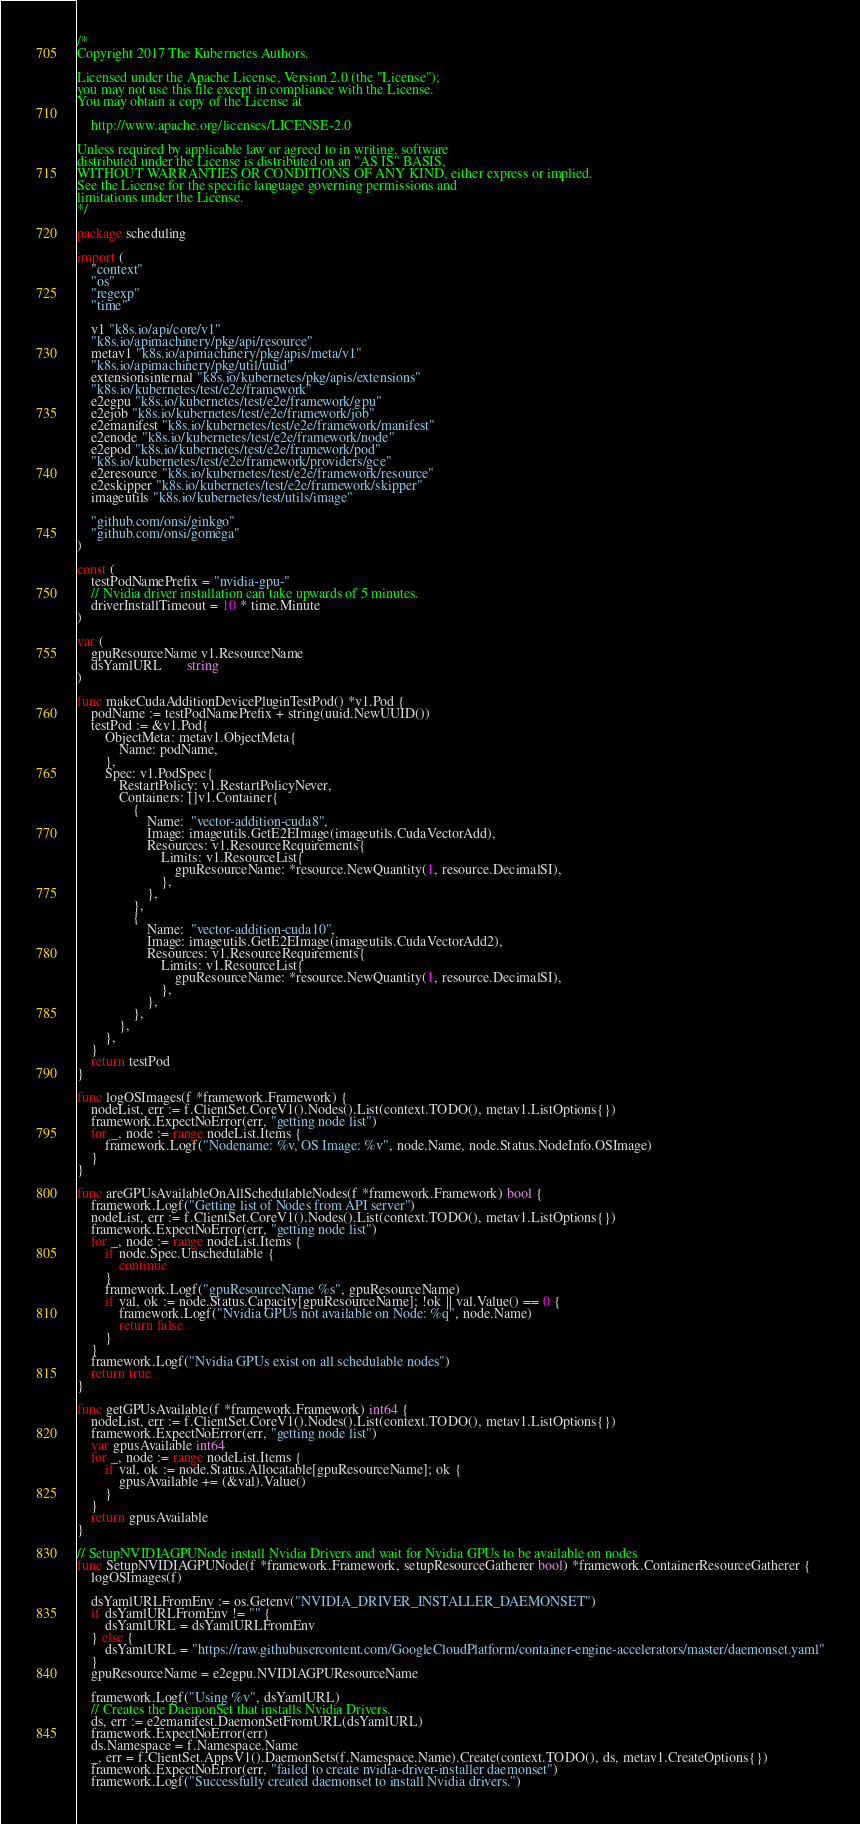<code> <loc_0><loc_0><loc_500><loc_500><_Go_>/*
Copyright 2017 The Kubernetes Authors.

Licensed under the Apache License, Version 2.0 (the "License");
you may not use this file except in compliance with the License.
You may obtain a copy of the License at

    http://www.apache.org/licenses/LICENSE-2.0

Unless required by applicable law or agreed to in writing, software
distributed under the License is distributed on an "AS IS" BASIS,
WITHOUT WARRANTIES OR CONDITIONS OF ANY KIND, either express or implied.
See the License for the specific language governing permissions and
limitations under the License.
*/

package scheduling

import (
	"context"
	"os"
	"regexp"
	"time"

	v1 "k8s.io/api/core/v1"
	"k8s.io/apimachinery/pkg/api/resource"
	metav1 "k8s.io/apimachinery/pkg/apis/meta/v1"
	"k8s.io/apimachinery/pkg/util/uuid"
	extensionsinternal "k8s.io/kubernetes/pkg/apis/extensions"
	"k8s.io/kubernetes/test/e2e/framework"
	e2egpu "k8s.io/kubernetes/test/e2e/framework/gpu"
	e2ejob "k8s.io/kubernetes/test/e2e/framework/job"
	e2emanifest "k8s.io/kubernetes/test/e2e/framework/manifest"
	e2enode "k8s.io/kubernetes/test/e2e/framework/node"
	e2epod "k8s.io/kubernetes/test/e2e/framework/pod"
	"k8s.io/kubernetes/test/e2e/framework/providers/gce"
	e2eresource "k8s.io/kubernetes/test/e2e/framework/resource"
	e2eskipper "k8s.io/kubernetes/test/e2e/framework/skipper"
	imageutils "k8s.io/kubernetes/test/utils/image"

	"github.com/onsi/ginkgo"
	"github.com/onsi/gomega"
)

const (
	testPodNamePrefix = "nvidia-gpu-"
	// Nvidia driver installation can take upwards of 5 minutes.
	driverInstallTimeout = 10 * time.Minute
)

var (
	gpuResourceName v1.ResourceName
	dsYamlURL       string
)

func makeCudaAdditionDevicePluginTestPod() *v1.Pod {
	podName := testPodNamePrefix + string(uuid.NewUUID())
	testPod := &v1.Pod{
		ObjectMeta: metav1.ObjectMeta{
			Name: podName,
		},
		Spec: v1.PodSpec{
			RestartPolicy: v1.RestartPolicyNever,
			Containers: []v1.Container{
				{
					Name:  "vector-addition-cuda8",
					Image: imageutils.GetE2EImage(imageutils.CudaVectorAdd),
					Resources: v1.ResourceRequirements{
						Limits: v1.ResourceList{
							gpuResourceName: *resource.NewQuantity(1, resource.DecimalSI),
						},
					},
				},
				{
					Name:  "vector-addition-cuda10",
					Image: imageutils.GetE2EImage(imageutils.CudaVectorAdd2),
					Resources: v1.ResourceRequirements{
						Limits: v1.ResourceList{
							gpuResourceName: *resource.NewQuantity(1, resource.DecimalSI),
						},
					},
				},
			},
		},
	}
	return testPod
}

func logOSImages(f *framework.Framework) {
	nodeList, err := f.ClientSet.CoreV1().Nodes().List(context.TODO(), metav1.ListOptions{})
	framework.ExpectNoError(err, "getting node list")
	for _, node := range nodeList.Items {
		framework.Logf("Nodename: %v, OS Image: %v", node.Name, node.Status.NodeInfo.OSImage)
	}
}

func areGPUsAvailableOnAllSchedulableNodes(f *framework.Framework) bool {
	framework.Logf("Getting list of Nodes from API server")
	nodeList, err := f.ClientSet.CoreV1().Nodes().List(context.TODO(), metav1.ListOptions{})
	framework.ExpectNoError(err, "getting node list")
	for _, node := range nodeList.Items {
		if node.Spec.Unschedulable {
			continue
		}
		framework.Logf("gpuResourceName %s", gpuResourceName)
		if val, ok := node.Status.Capacity[gpuResourceName]; !ok || val.Value() == 0 {
			framework.Logf("Nvidia GPUs not available on Node: %q", node.Name)
			return false
		}
	}
	framework.Logf("Nvidia GPUs exist on all schedulable nodes")
	return true
}

func getGPUsAvailable(f *framework.Framework) int64 {
	nodeList, err := f.ClientSet.CoreV1().Nodes().List(context.TODO(), metav1.ListOptions{})
	framework.ExpectNoError(err, "getting node list")
	var gpusAvailable int64
	for _, node := range nodeList.Items {
		if val, ok := node.Status.Allocatable[gpuResourceName]; ok {
			gpusAvailable += (&val).Value()
		}
	}
	return gpusAvailable
}

// SetupNVIDIAGPUNode install Nvidia Drivers and wait for Nvidia GPUs to be available on nodes
func SetupNVIDIAGPUNode(f *framework.Framework, setupResourceGatherer bool) *framework.ContainerResourceGatherer {
	logOSImages(f)

	dsYamlURLFromEnv := os.Getenv("NVIDIA_DRIVER_INSTALLER_DAEMONSET")
	if dsYamlURLFromEnv != "" {
		dsYamlURL = dsYamlURLFromEnv
	} else {
		dsYamlURL = "https://raw.githubusercontent.com/GoogleCloudPlatform/container-engine-accelerators/master/daemonset.yaml"
	}
	gpuResourceName = e2egpu.NVIDIAGPUResourceName

	framework.Logf("Using %v", dsYamlURL)
	// Creates the DaemonSet that installs Nvidia Drivers.
	ds, err := e2emanifest.DaemonSetFromURL(dsYamlURL)
	framework.ExpectNoError(err)
	ds.Namespace = f.Namespace.Name
	_, err = f.ClientSet.AppsV1().DaemonSets(f.Namespace.Name).Create(context.TODO(), ds, metav1.CreateOptions{})
	framework.ExpectNoError(err, "failed to create nvidia-driver-installer daemonset")
	framework.Logf("Successfully created daemonset to install Nvidia drivers.")
</code> 